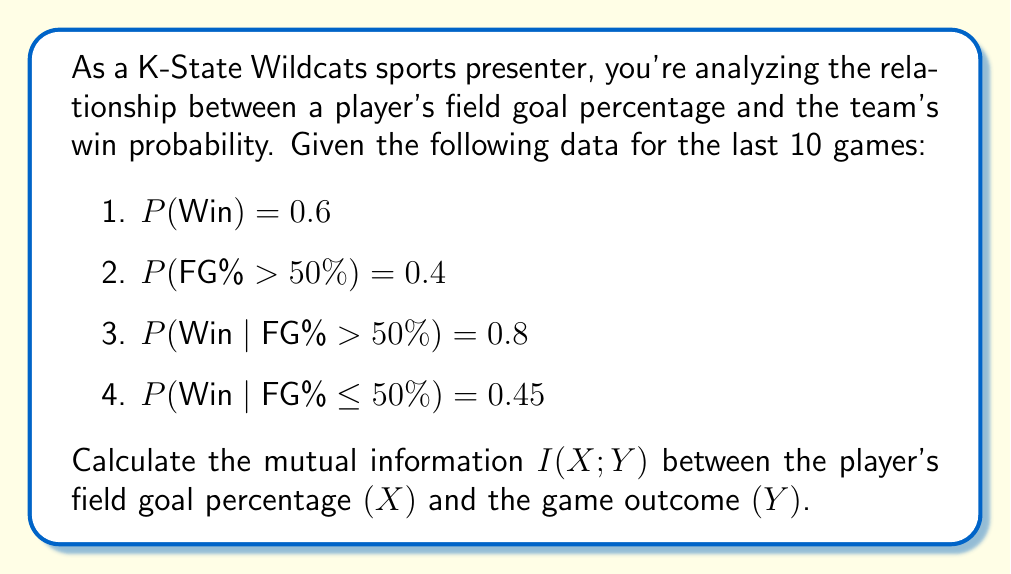Provide a solution to this math problem. To calculate the mutual information I(X;Y), we'll follow these steps:

1. Calculate P(FG% ≤ 50%) and P(Loss):
   P(FG% ≤ 50%) = 1 - P(FG% > 50%) = 1 - 0.4 = 0.6
   P(Loss) = 1 - P(Win) = 1 - 0.6 = 0.4

2. Calculate P(Win, FG% > 50%) and P(Win, FG% ≤ 50%):
   P(Win, FG% > 50%) = P(Win | FG% > 50%) * P(FG% > 50%) = 0.8 * 0.4 = 0.32
   P(Win, FG% ≤ 50%) = P(Win | FG% ≤ 50%) * P(FG% ≤ 50%) = 0.45 * 0.6 = 0.27

3. Calculate P(Loss, FG% > 50%) and P(Loss, FG% ≤ 50%):
   P(Loss, FG% > 50%) = P(FG% > 50%) - P(Win, FG% > 50%) = 0.4 - 0.32 = 0.08
   P(Loss, FG% ≤ 50%) = P(FG% ≤ 50%) - P(Win, FG% ≤ 50%) = 0.6 - 0.27 = 0.33

4. Use the formula for mutual information:
   $$I(X;Y) = \sum_{x \in X} \sum_{y \in Y} P(x,y) \log_2 \frac{P(x,y)}{P(x)P(y)}$$

5. Calculate each term:
   $$\begin{align*}
   &0.32 \log_2 \frac{0.32}{0.4 * 0.6} + 0.27 \log_2 \frac{0.27}{0.6 * 0.6} \\
   &+ 0.08 \log_2 \frac{0.08}{0.4 * 0.4} + 0.33 \log_2 \frac{0.33}{0.6 * 0.4}
   \end{align*}$$

6. Compute the final result:
   $$\begin{align*}
   I(X;Y) &= 0.32 \log_2 1.3333 + 0.27 \log_2 0.75 + 0.08 \log_2 0.5 + 0.33 \log_2 1.375 \\
   &≈ 0.1127 + (-0.0874) + (-0.0800) + 0.1509 \\
   &≈ 0.0962 \text{ bits}
   \end{align*}$$
Answer: The mutual information I(X;Y) between the player's field goal percentage and the game outcome is approximately 0.0962 bits. 